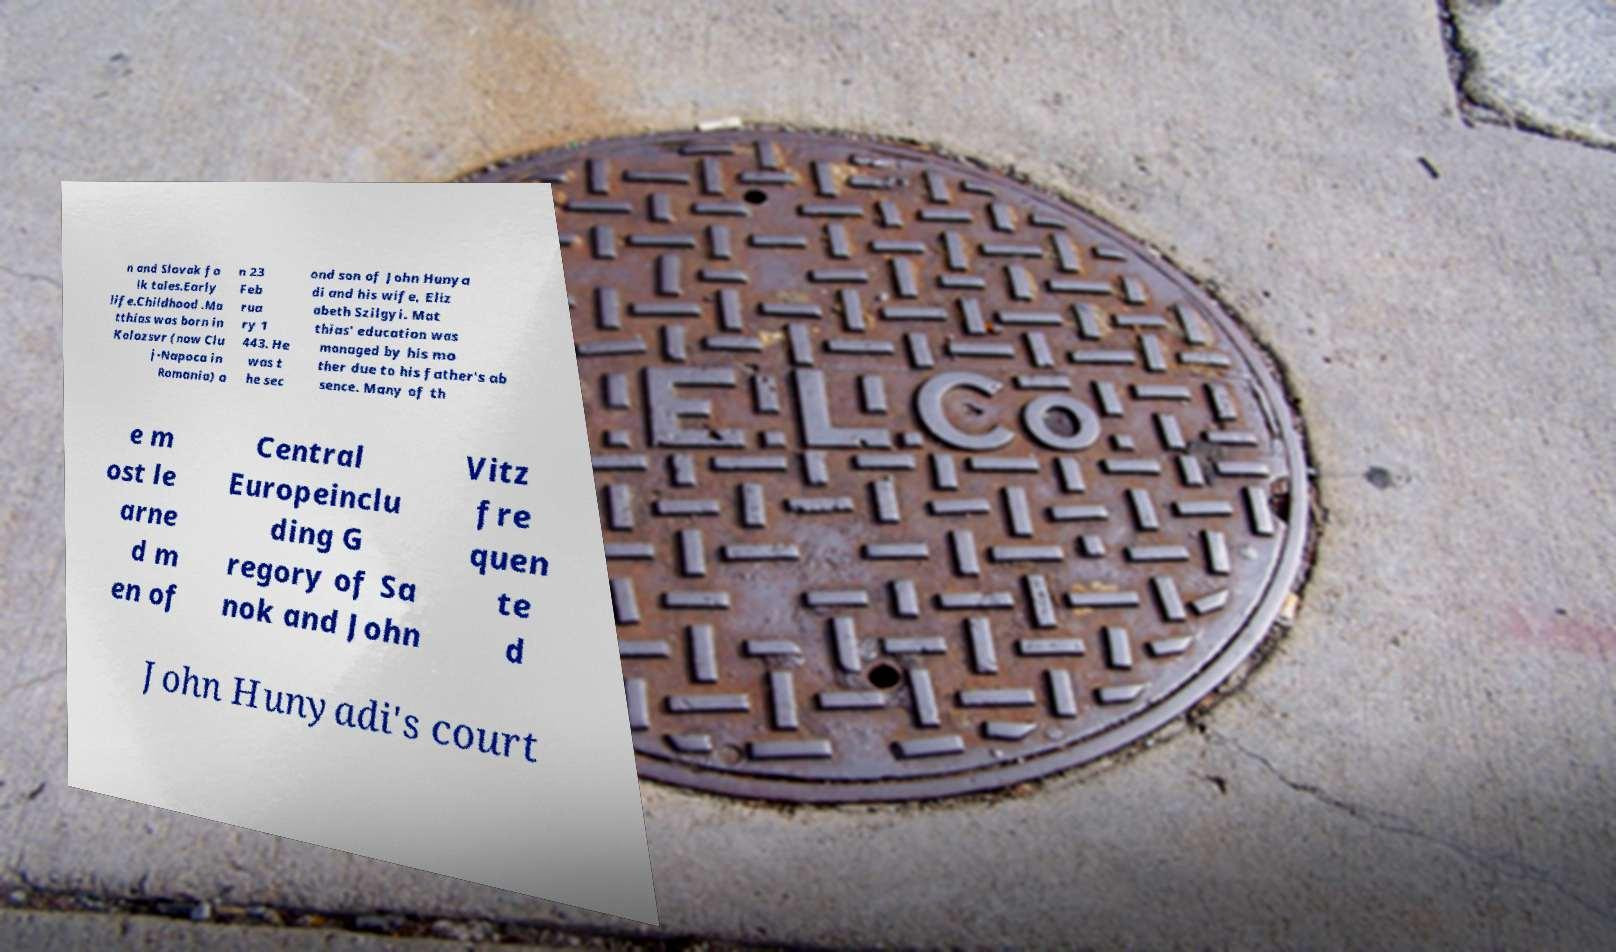Could you assist in decoding the text presented in this image and type it out clearly? n and Slovak fo lk tales.Early life.Childhood .Ma tthias was born in Kolozsvr (now Clu j-Napoca in Romania) o n 23 Feb rua ry 1 443. He was t he sec ond son of John Hunya di and his wife, Eliz abeth Szilgyi. Mat thias' education was managed by his mo ther due to his father's ab sence. Many of th e m ost le arne d m en of Central Europeinclu ding G regory of Sa nok and John Vitz fre quen te d John Hunyadi's court 